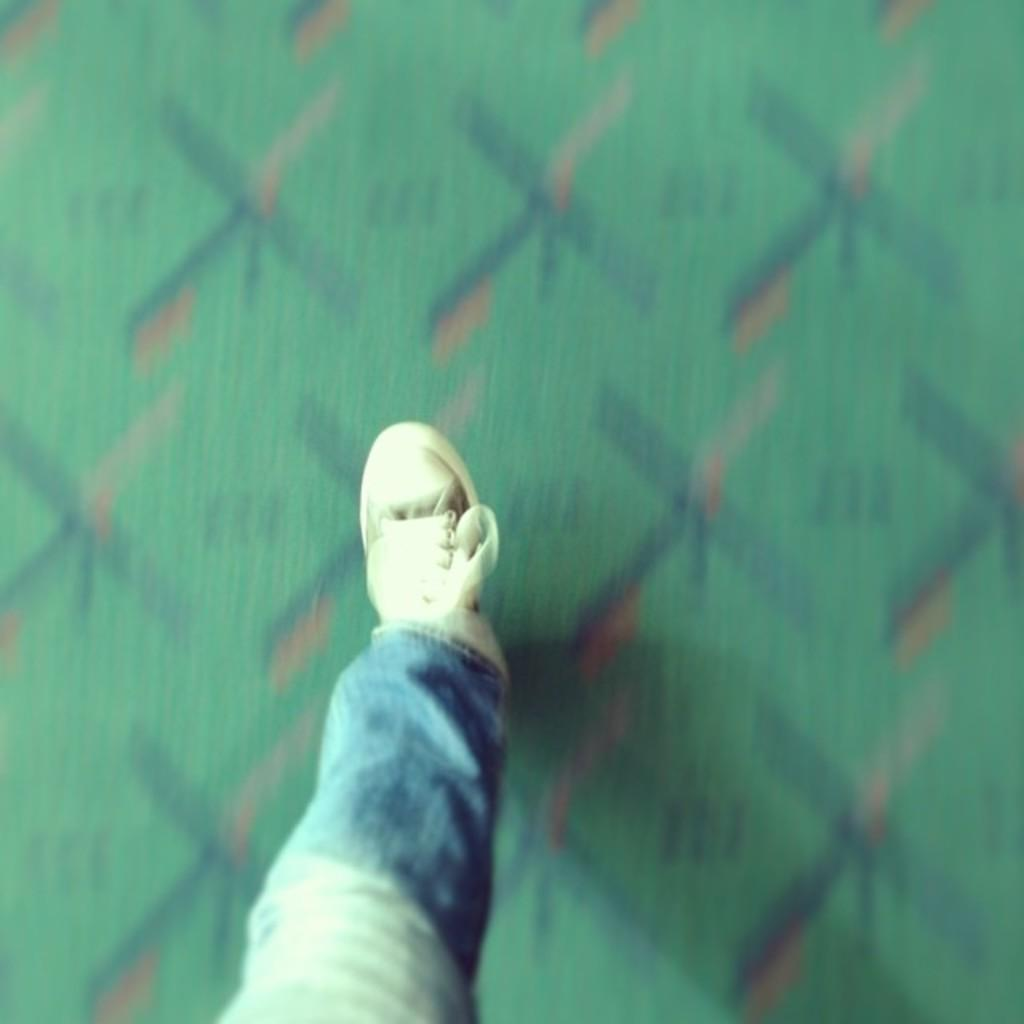What part of a person's body is visible in the image? There is a person's leg in the image. Can you describe the background of the image? The background of the image is blurred. What type of flower is growing next to the scarecrow in the image? There is no scarecrow or flower present in the image; it only features a person's leg and a blurred background. 